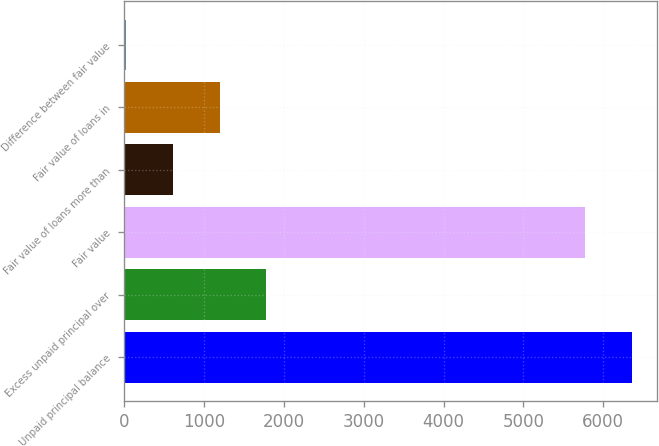Convert chart to OTSL. <chart><loc_0><loc_0><loc_500><loc_500><bar_chart><fcel>Unpaid principal balance<fcel>Excess unpaid principal over<fcel>Fair value<fcel>Fair value of loans more than<fcel>Fair value of loans in<fcel>Difference between fair value<nl><fcel>6355.6<fcel>1778.8<fcel>5771<fcel>609.6<fcel>1194.2<fcel>25<nl></chart> 